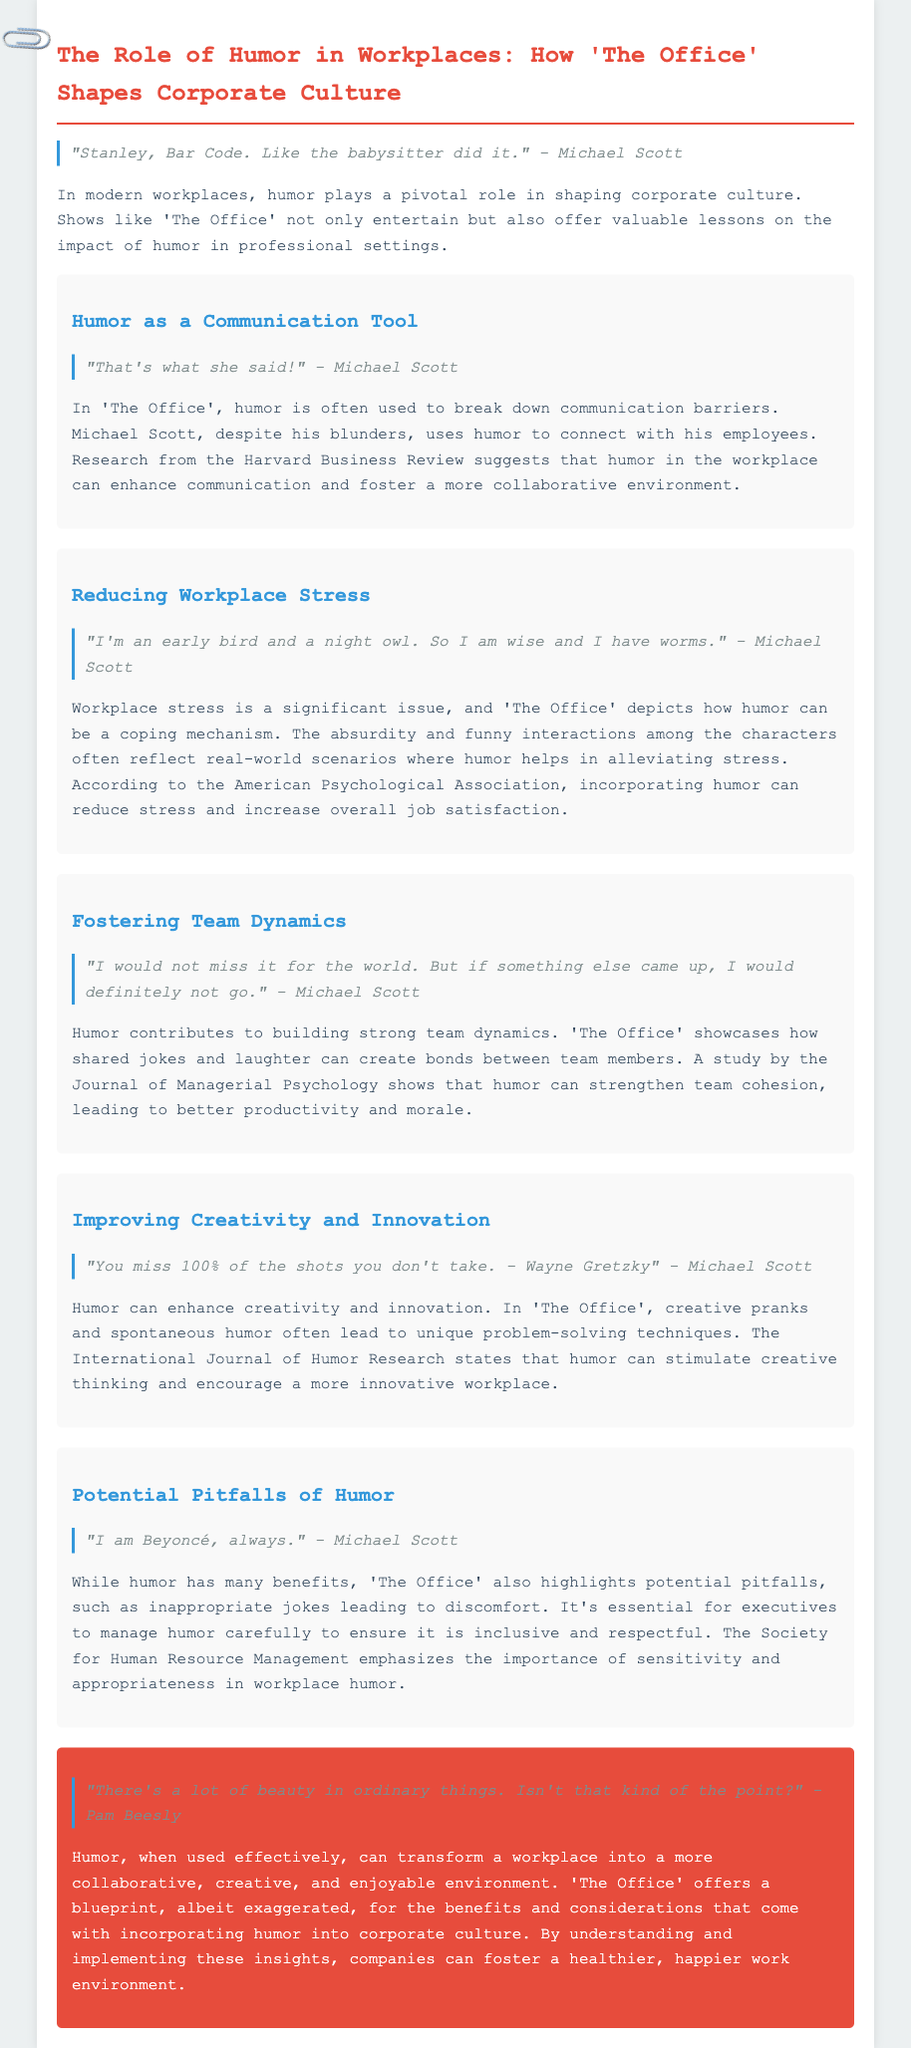what is the title of the whitepaper? The title is stated at the top of the document.
Answer: The Role of Humor in Workplaces: How 'The Office' Shapes Corporate Culture what role does humor play in workplaces, according to the document? The document summarizes the various impacts of humor on workplace culture.
Answer: Pivotal role who is a quoted character known for their humor in 'The Office'? The document includes numerous quotes from characters in the show.
Answer: Michael Scott which organization suggests that humor in the workplace can enhance communication? The specific source of the research is mentioned in the section discussing humor as a communication tool.
Answer: Harvard Business Review what is a potential pitfall of humor mentioned in the document? The document addresses the negative aspects of humor in the workplace.
Answer: Inappropriate jokes how can humor affect workplace stress, as per the whitepaper? The document discusses how humor relates to stress relief within the workplace.
Answer: Alleviating stress which character is quoted saying, "You miss 100% of the shots you don't take"? This quote is included in the section about enhancing creativity and innovation.
Answer: Michael Scott what does the document state can strengthen team cohesion? The relevant section discusses the impact of shared jokes and laughter.
Answer: Humor what is the conclusion about the role of humor in the workplace? The final section summarizes the overall impact of humor when used correctly.
Answer: Transform a workplace into a more collaborative, creative, and enjoyable environment 